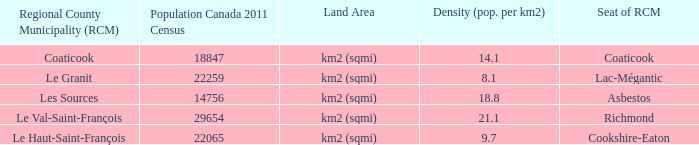What is the land area for the RCM that has a population of 18847? Km2 (sqmi). 